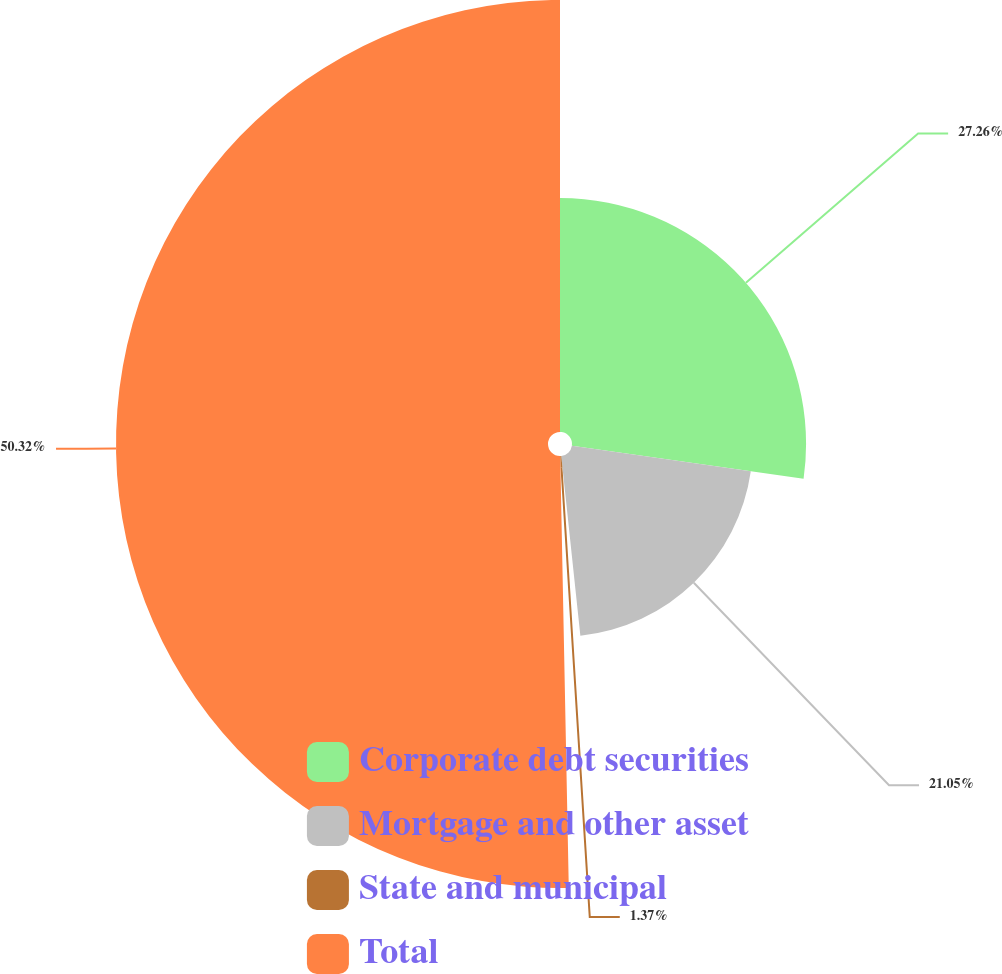<chart> <loc_0><loc_0><loc_500><loc_500><pie_chart><fcel>Corporate debt securities<fcel>Mortgage and other asset<fcel>State and municipal<fcel>Total<nl><fcel>27.26%<fcel>21.05%<fcel>1.37%<fcel>50.31%<nl></chart> 